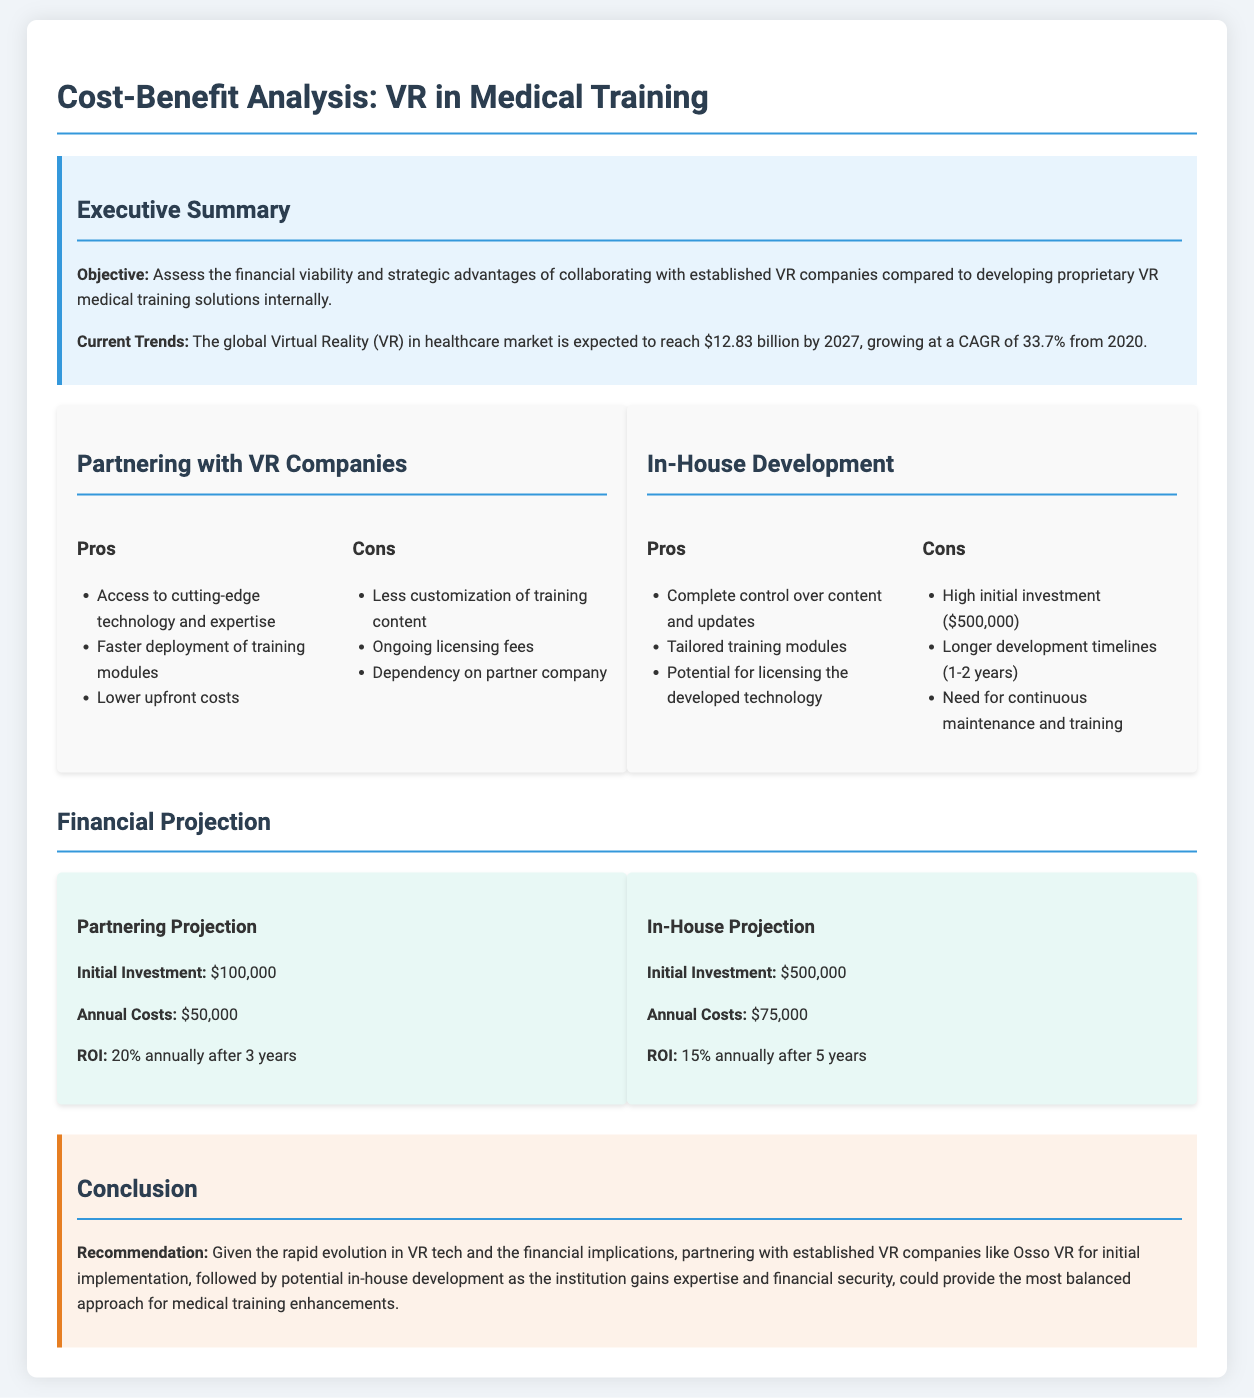what is the initial investment for in-house development? The initial investment for in-house development is found in the financial projection section of the document, which states it is $500,000.
Answer: $500,000 what is the expected CAGR for the VR in healthcare market? The expected CAGR is mentioned in the executive summary, indicating it is 33.7% from 2020.
Answer: 33.7% how long are the development timelines for in-house solutions? The development timelines for in-house solutions are discussed in the pros and cons section, which states they range from 1 to 2 years.
Answer: 1-2 years what is the ROI for partnering with VR companies after 3 years? The ROI is found in the financial projection part of the document, stating it is 20% annually after 3 years.
Answer: 20% what are the total annual costs for partnering with VR companies? The total annual costs for partnering are listed in the financial projection section as $50,000.
Answer: $50,000 what is the recommendation from the conclusion section? The recommendation is included in the conclusion, which suggests partnering with established VR companies for initial implementation.
Answer: Partnering with established VR companies what amount of ongoing licensing fees is associated with partnering? Ongoing licensing fees are mentioned as a con in the pros and cons section, implying these fees will be a consideration but are not quantified.
Answer: Not specified what is one potential benefit of in-house development mentioned? One potential benefit of in-house development is the ability to have complete control over content and updates, mentioned in the pros section.
Answer: Complete control over content and updates what does the expected future market value of the VR healthcare market reach by 2027? The expected future market value is provided in the executive summary, indicating it is projected to reach $12.83 billion.
Answer: $12.83 billion 